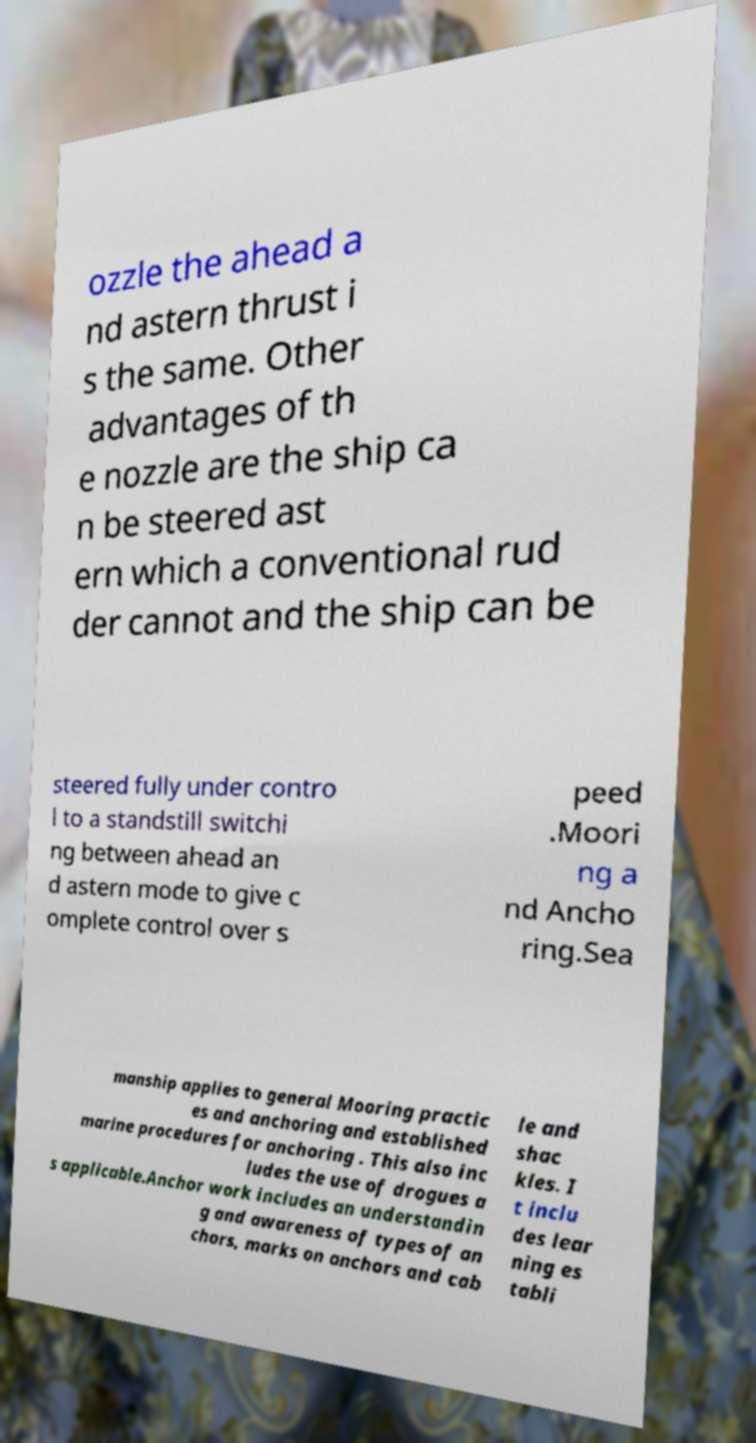There's text embedded in this image that I need extracted. Can you transcribe it verbatim? ozzle the ahead a nd astern thrust i s the same. Other advantages of th e nozzle are the ship ca n be steered ast ern which a conventional rud der cannot and the ship can be steered fully under contro l to a standstill switchi ng between ahead an d astern mode to give c omplete control over s peed .Moori ng a nd Ancho ring.Sea manship applies to general Mooring practic es and anchoring and established marine procedures for anchoring . This also inc ludes the use of drogues a s applicable.Anchor work includes an understandin g and awareness of types of an chors, marks on anchors and cab le and shac kles. I t inclu des lear ning es tabli 